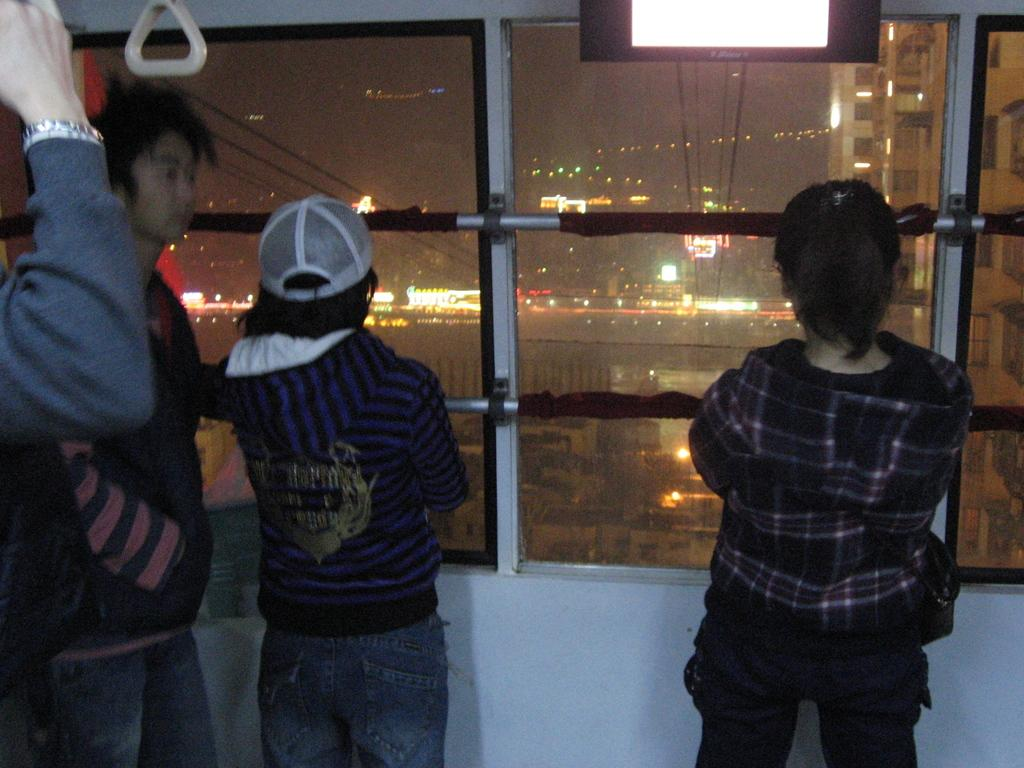Who or what can be seen in the image? There are people in the image. What is the primary object in the image? There is a screen in the image. What else can be seen in the image besides the people and screen? There are rods, glasses, and an object in the image. What can be seen through the glasses in the image? Buildings and lights are visible through the glass. What type of feast is being prepared on the screen in the image? There is no feast being prepared on the screen in the image; it is not mentioned or depicted. 